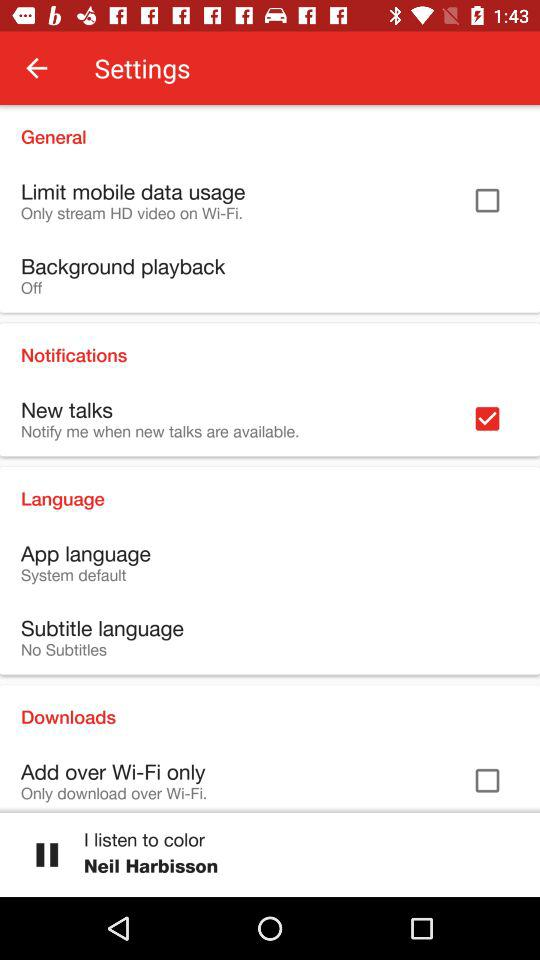What's the setting for the background playback? The setting is "off". 